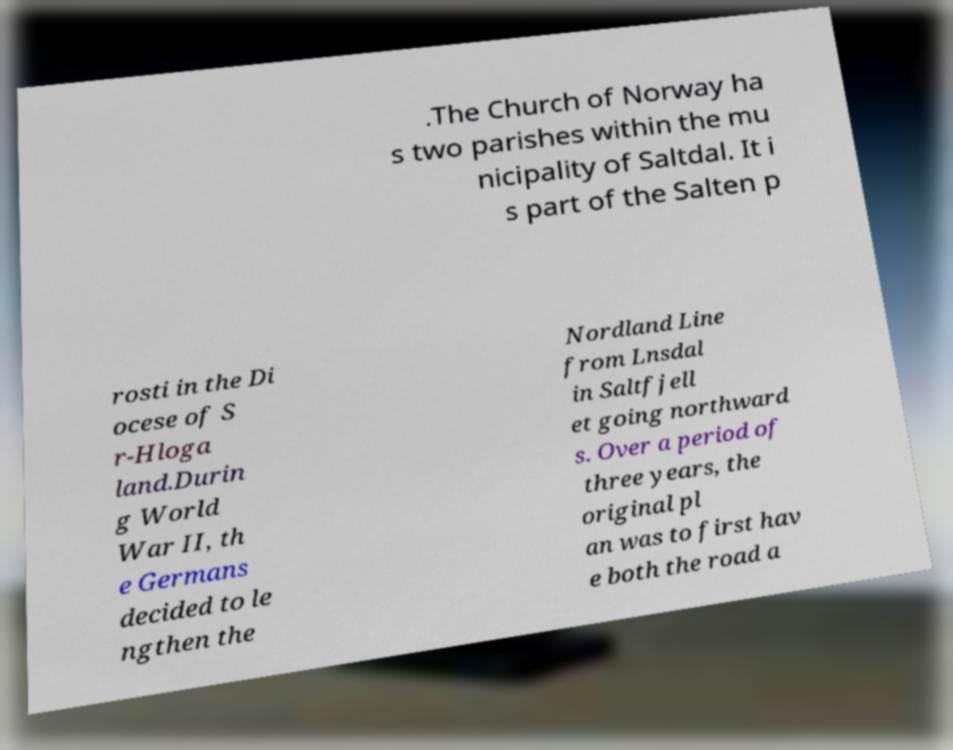For documentation purposes, I need the text within this image transcribed. Could you provide that? .The Church of Norway ha s two parishes within the mu nicipality of Saltdal. It i s part of the Salten p rosti in the Di ocese of S r-Hloga land.Durin g World War II, th e Germans decided to le ngthen the Nordland Line from Lnsdal in Saltfjell et going northward s. Over a period of three years, the original pl an was to first hav e both the road a 